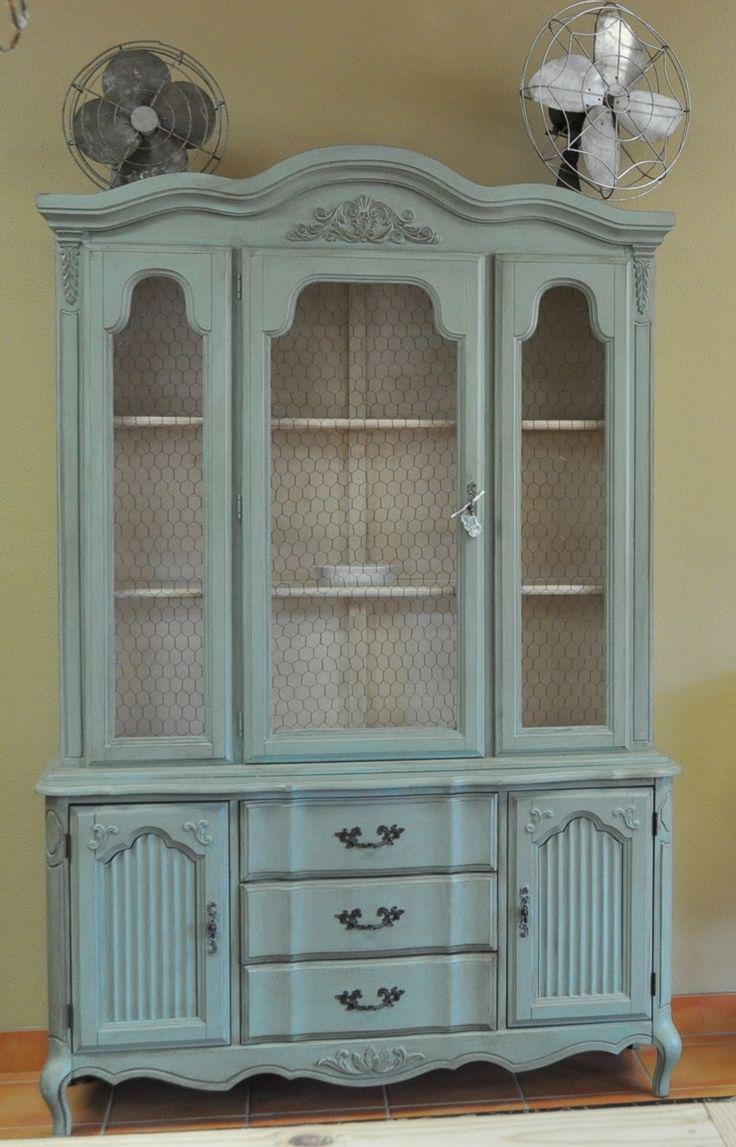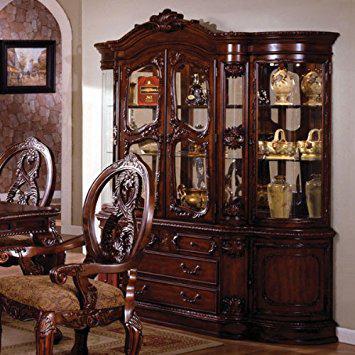The first image is the image on the left, the second image is the image on the right. Analyze the images presented: Is the assertion "In one image, a wooden hutch sits on short legs and has three doors at the top, three at the bottom, and two drawers in the middle." valid? Answer yes or no. No. The first image is the image on the left, the second image is the image on the right. Considering the images on both sides, is "An image shows a cabinet with a non-flat top and with feet." valid? Answer yes or no. Yes. 